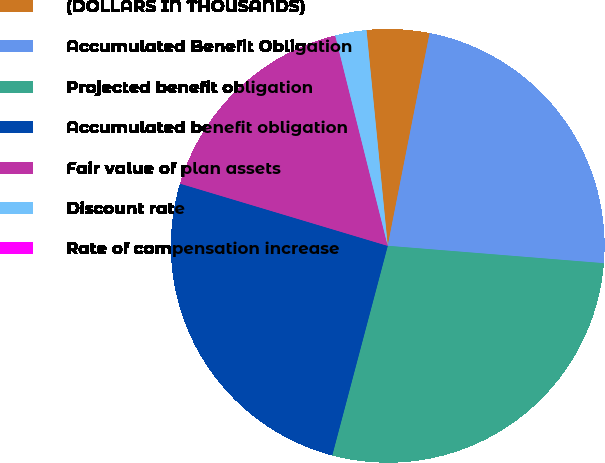Convert chart. <chart><loc_0><loc_0><loc_500><loc_500><pie_chart><fcel>(DOLLARS IN THOUSANDS)<fcel>Accumulated Benefit Obligation<fcel>Projected benefit obligation<fcel>Accumulated benefit obligation<fcel>Fair value of plan assets<fcel>Discount rate<fcel>Rate of compensation increase<nl><fcel>4.66%<fcel>23.18%<fcel>27.84%<fcel>25.51%<fcel>16.47%<fcel>2.33%<fcel>0.0%<nl></chart> 